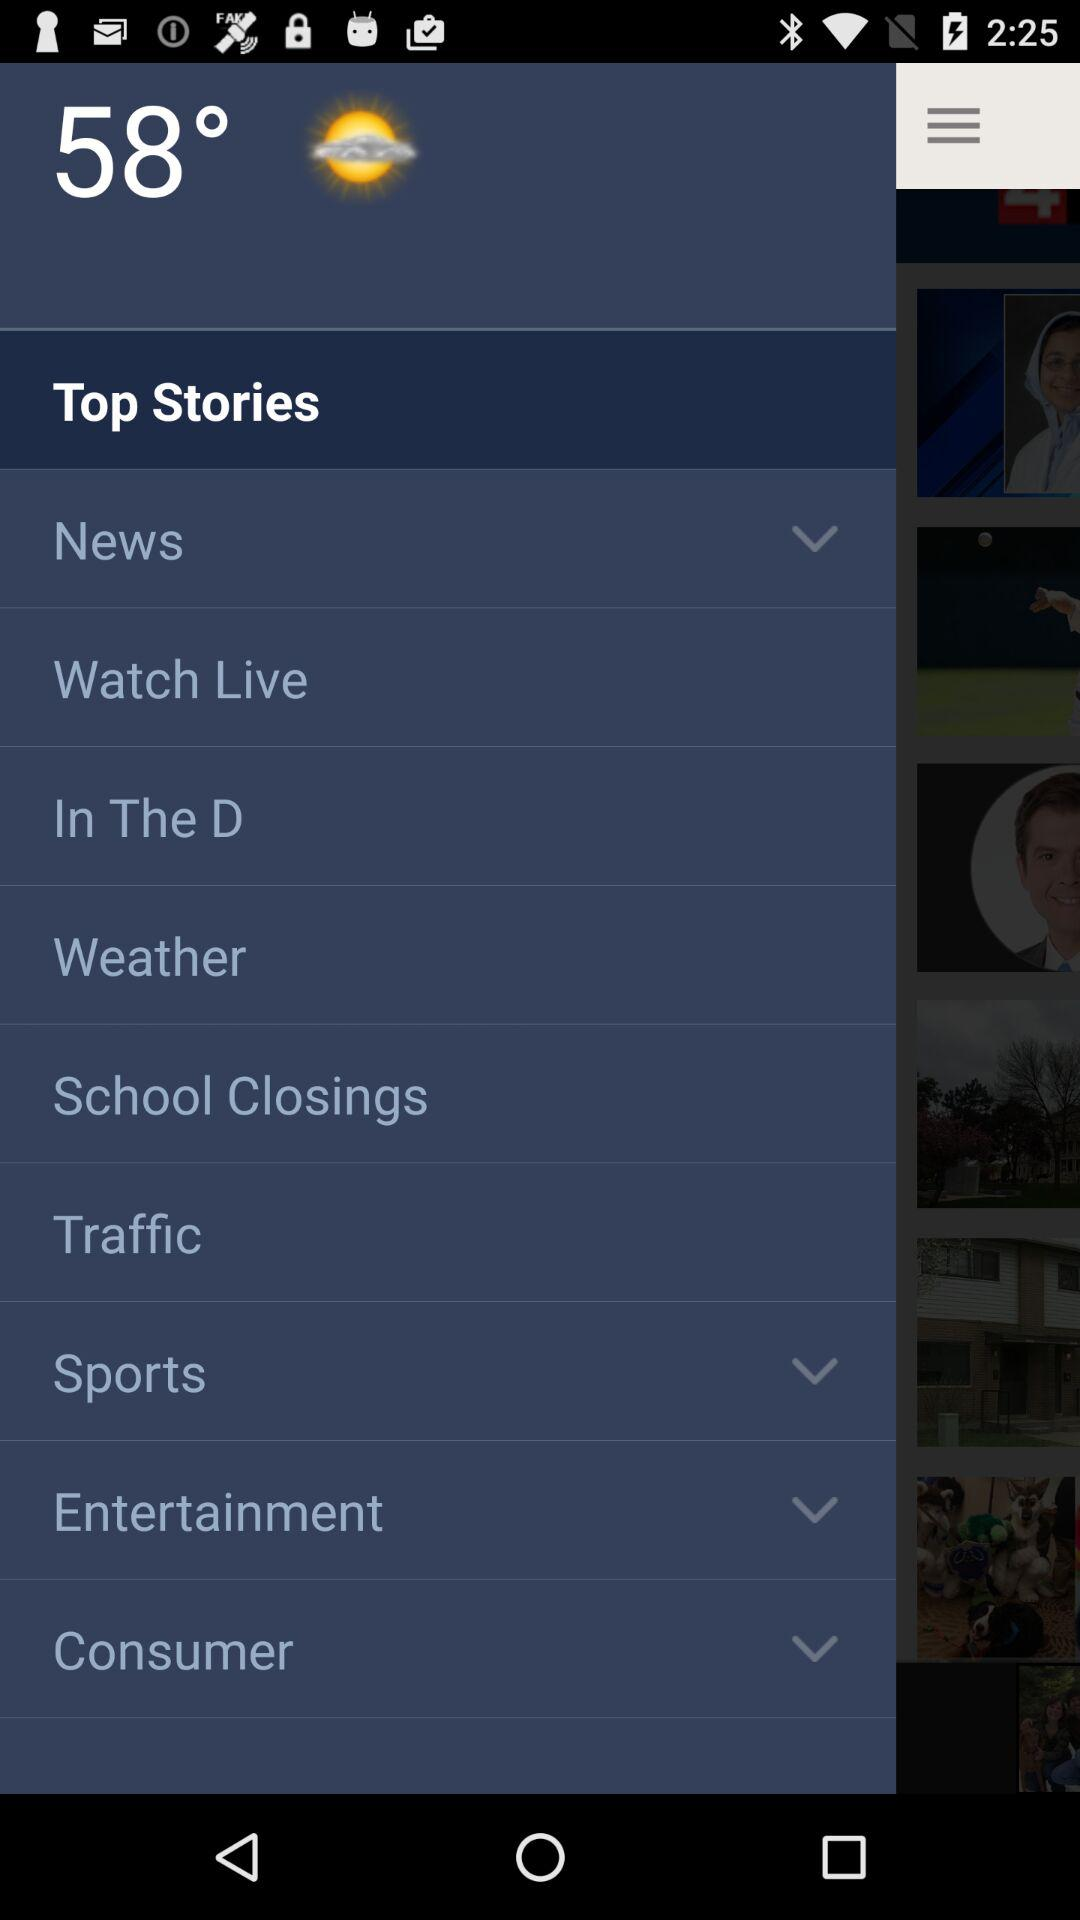What's the temperature? The temperature is 58°. 